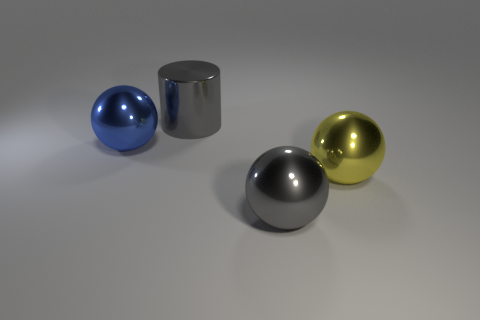The big metallic ball that is right of the gray object in front of the yellow thing is what color?
Ensure brevity in your answer.  Yellow. There is a metal ball that is left of the big gray cylinder; does it have the same color as the big cylinder?
Offer a terse response. No. Do the gray metal ball and the cylinder have the same size?
Keep it short and to the point. Yes. There is a gray thing that is the same size as the gray ball; what is its shape?
Offer a very short reply. Cylinder. There is a blue metallic thing left of the cylinder; is it the same size as the big gray sphere?
Offer a very short reply. Yes. What material is the cylinder that is the same size as the blue metal object?
Offer a terse response. Metal. There is a large gray metal thing in front of the large sphere on the left side of the big gray sphere; are there any large gray shiny things that are to the right of it?
Ensure brevity in your answer.  No. Is there anything else that is the same shape as the yellow thing?
Keep it short and to the point. Yes. Does the metal ball that is on the left side of the gray metal cylinder have the same color as the thing behind the blue ball?
Keep it short and to the point. No. Are there any blue spheres?
Give a very brief answer. Yes. 